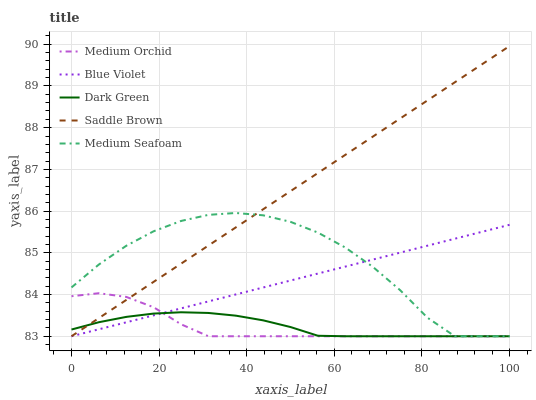Does Medium Orchid have the minimum area under the curve?
Answer yes or no. Yes. Does Saddle Brown have the maximum area under the curve?
Answer yes or no. Yes. Does Saddle Brown have the minimum area under the curve?
Answer yes or no. No. Does Medium Orchid have the maximum area under the curve?
Answer yes or no. No. Is Blue Violet the smoothest?
Answer yes or no. Yes. Is Medium Seafoam the roughest?
Answer yes or no. Yes. Is Medium Orchid the smoothest?
Answer yes or no. No. Is Medium Orchid the roughest?
Answer yes or no. No. Does Medium Seafoam have the lowest value?
Answer yes or no. Yes. Does Saddle Brown have the highest value?
Answer yes or no. Yes. Does Medium Orchid have the highest value?
Answer yes or no. No. Does Medium Seafoam intersect Medium Orchid?
Answer yes or no. Yes. Is Medium Seafoam less than Medium Orchid?
Answer yes or no. No. Is Medium Seafoam greater than Medium Orchid?
Answer yes or no. No. 